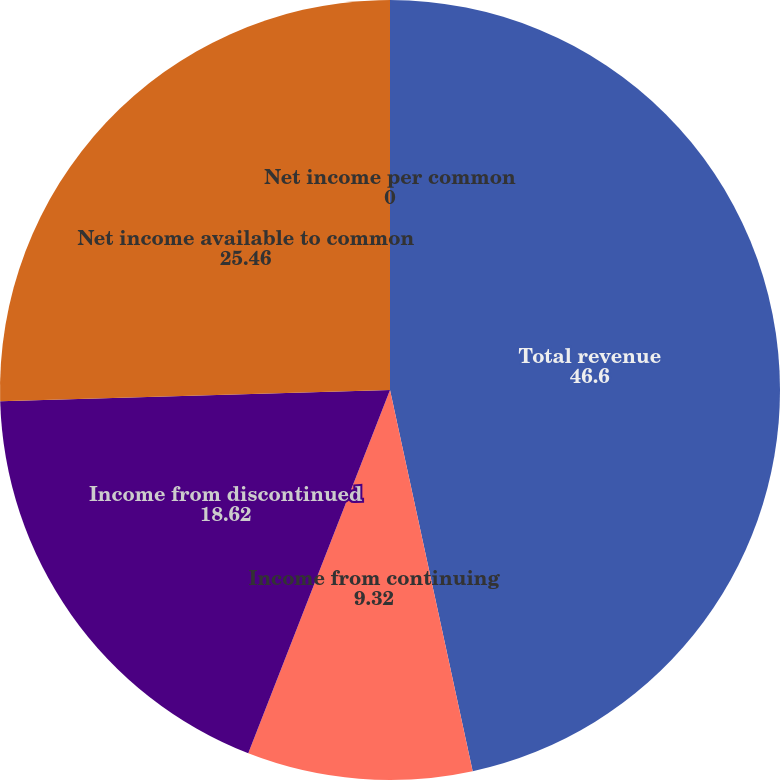Convert chart to OTSL. <chart><loc_0><loc_0><loc_500><loc_500><pie_chart><fcel>Total revenue<fcel>Income from continuing<fcel>Income from discontinued<fcel>Net income available to common<fcel>Net income per common<nl><fcel>46.6%<fcel>9.32%<fcel>18.62%<fcel>25.46%<fcel>0.0%<nl></chart> 